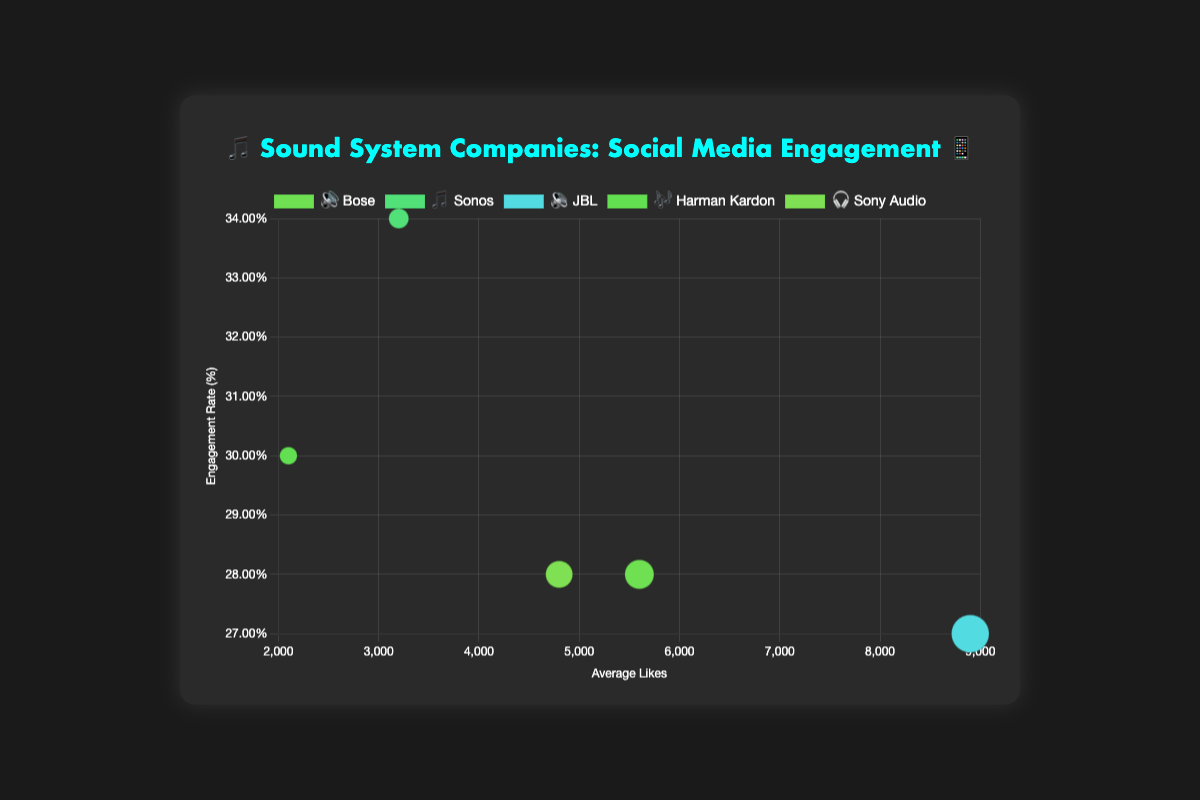How many companies are included in the chart? Count the number of different data points (circles) in the chart. Each point represents a company, and there are 5 companies shown.
Answer: 5 Which company has the highest engagement rate? Look at the y-axis which represents the engagement rate. The company with the highest y-coordinate has the highest engagement rate. Sonos has the highest engagement rate at 0.34 or 34%.
Answer: Sonos Which company has the most followers? The size of the bubbles corresponds to the number of followers. The largest bubble represents JBL with 3,500,000 followers.
Answer: JBL What is the average number of likes for Harman Kardon? Locate the bubble labeled Harman Kardon. Its x-coordinate gives the average number of likes, which is 2100.
Answer: 2100 How does the engagement rate of Bose compare to Sony Audio? Find the y-axis values for Bose and Sony Audio. Both companies have an engagement rate of 0.28 or 28%.
Answer: Equal What is the total number of average comments for all companies? Sum the avgComments values for all companies: 320 (Bose) + 180 (Sonos) + 520 (JBL) + 150 (Harman Kardon) + 280 (Sony Audio) = 1450.
Answer: 1450 Which company has the smallest average number of likes? Look at the x-axis for each company and find the smallest x-coordinate value. Harman Kardon has the smallest average likes at 2100.
Answer: Harman Kardon Which two companies have the closest engagement rates? Compare the y-axis values to find the two closest rates. Bose (0.28) and Sony Audio (0.28) have the exact same engagement rate.
Answer: Bose and Sony Audio 